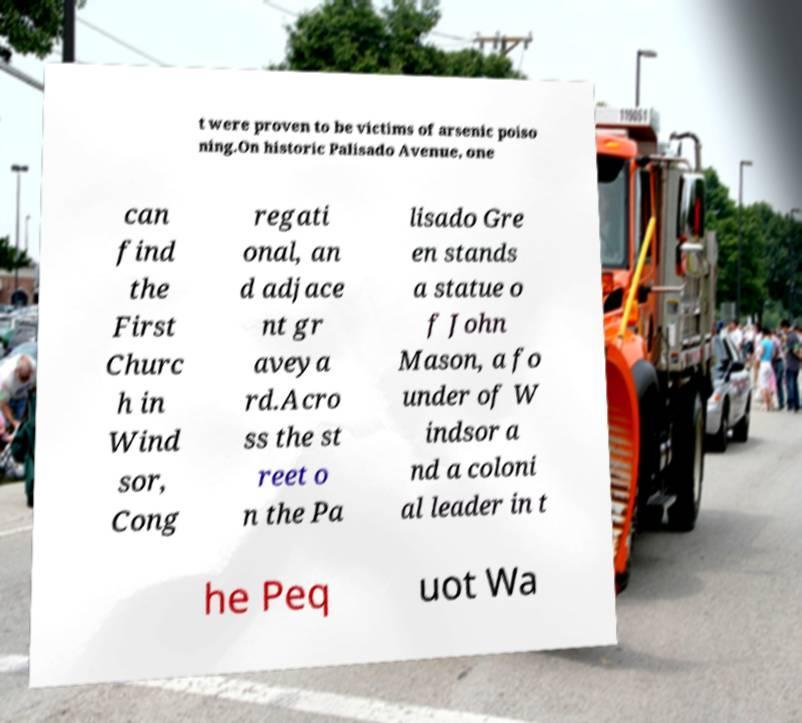Could you extract and type out the text from this image? t were proven to be victims of arsenic poiso ning.On historic Palisado Avenue, one can find the First Churc h in Wind sor, Cong regati onal, an d adjace nt gr aveya rd.Acro ss the st reet o n the Pa lisado Gre en stands a statue o f John Mason, a fo under of W indsor a nd a coloni al leader in t he Peq uot Wa 